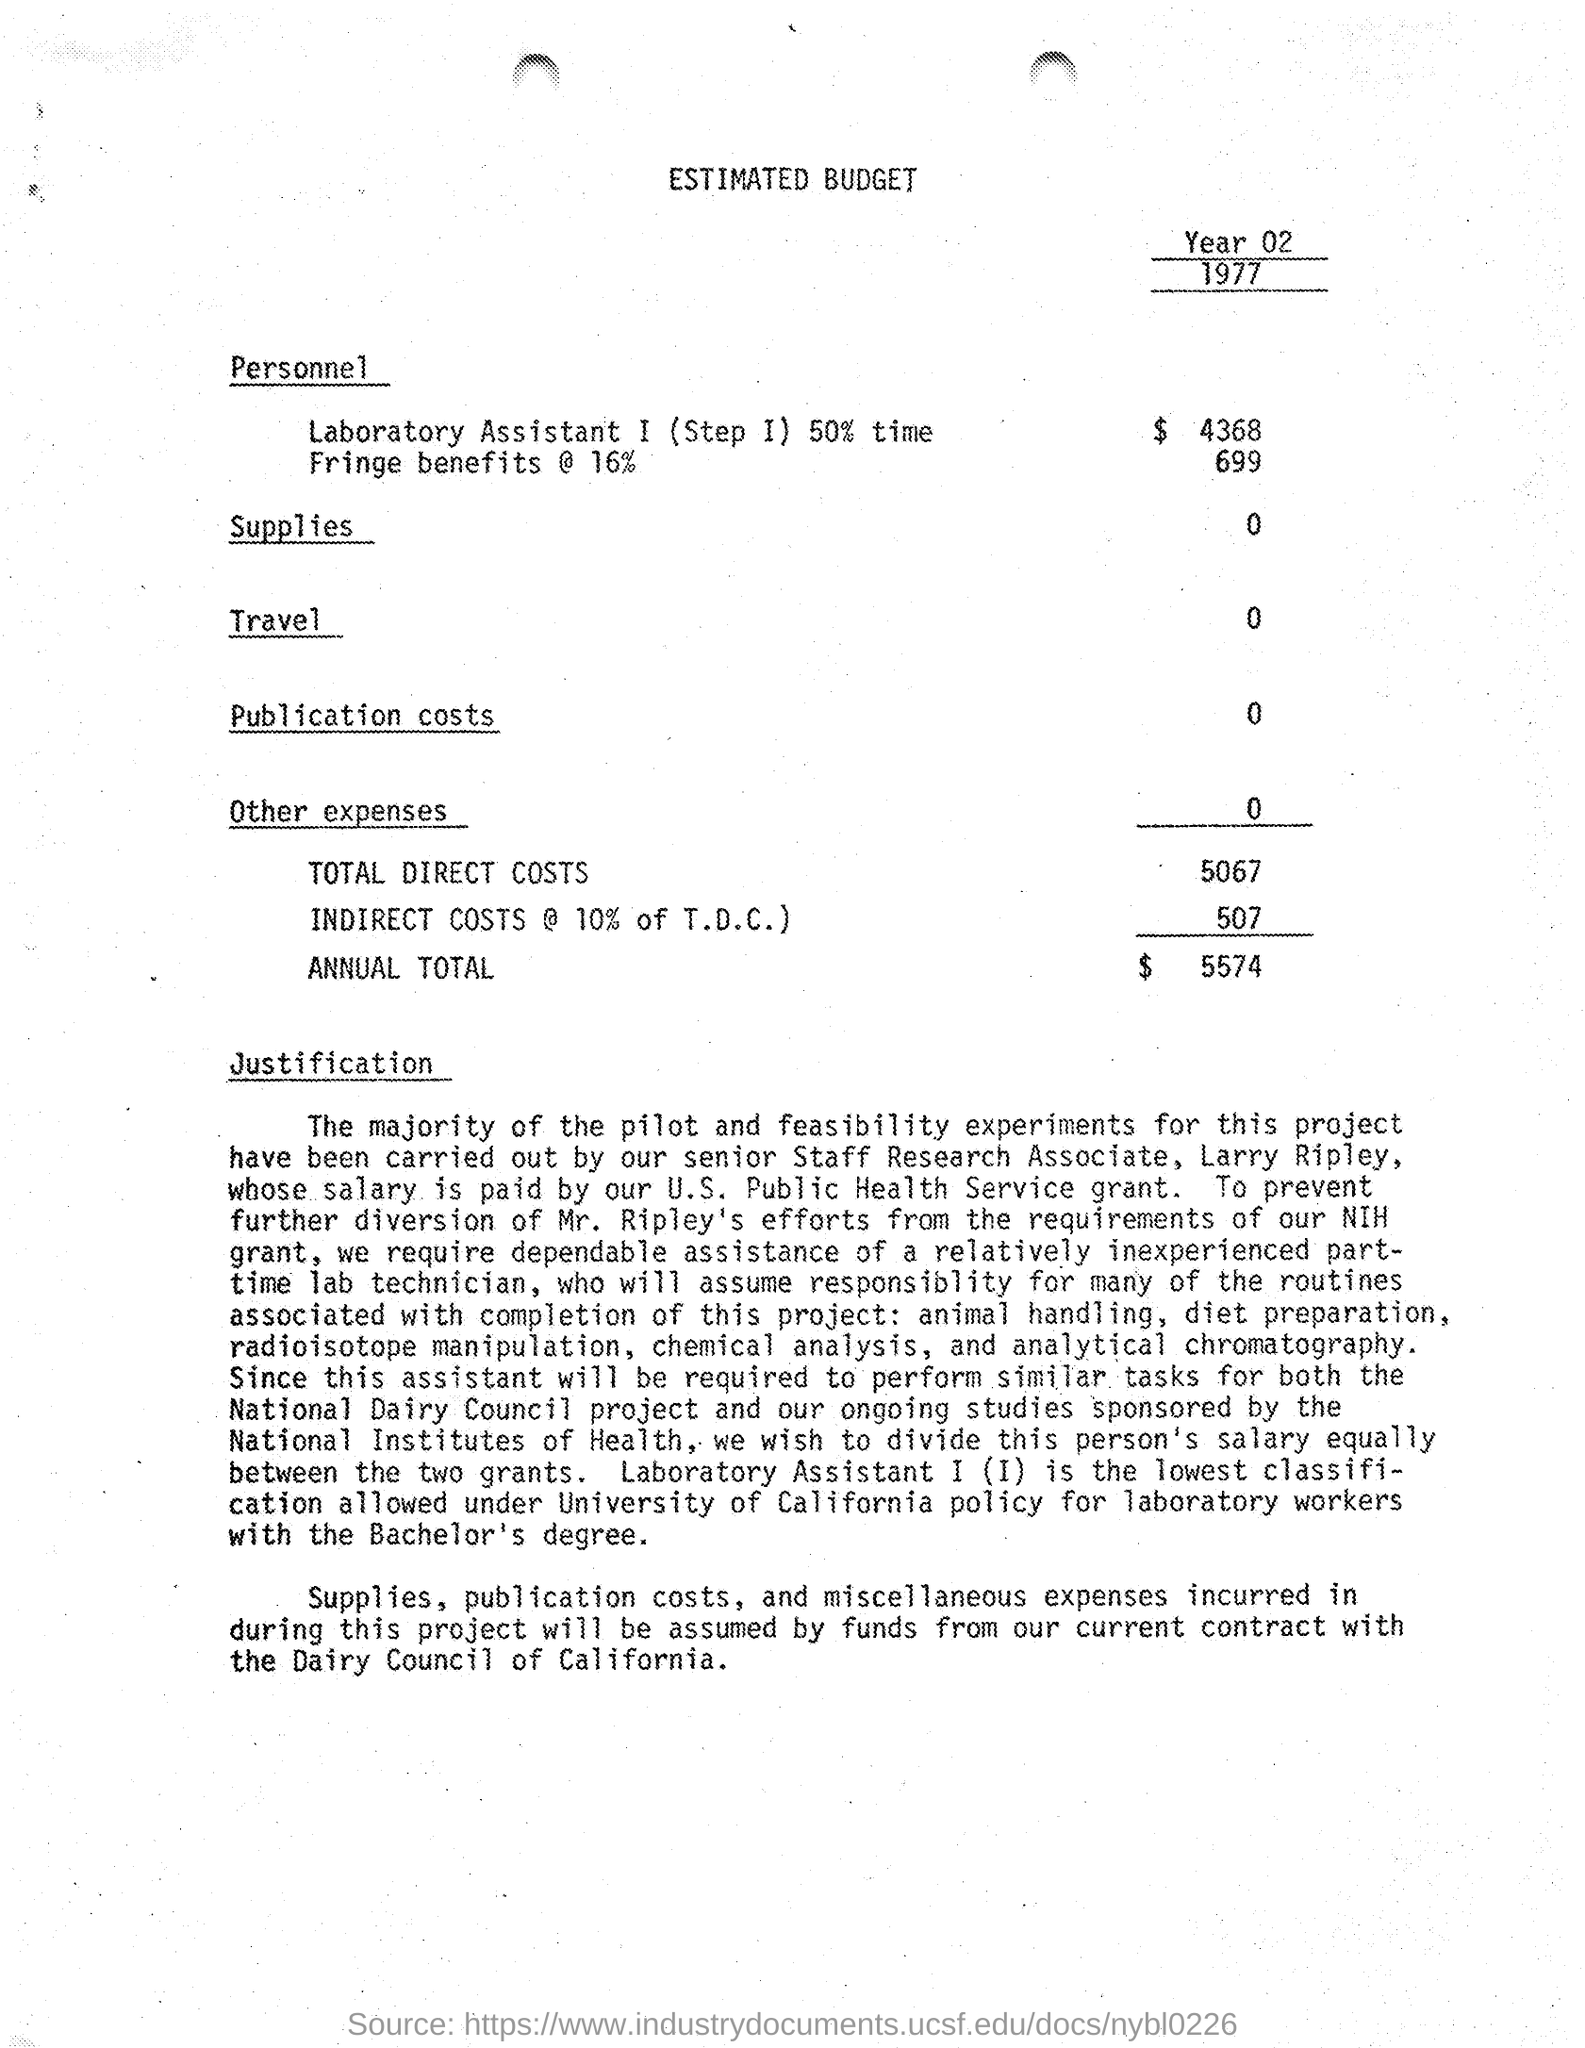What is the year of the estimated budget ?
Provide a short and direct response. Year 02. What is the amount for laboratory assistant 1 (step 1 ) 50% time as mentioned in the given budget ?
Provide a short and direct response. 4368. What is the amount given for fringe benefits @ 16 % as mentioned in the given budget ?
Provide a short and direct response. 699. What is the amount given for travel in the given budget ?
Make the answer very short. 0. What is the amount of total direct costs mentioned in the given budget ?
Your answer should be compact. 5067. What is the amount of indirect costs mentioned in the given budget ?
Offer a very short reply. 507. What is the amount of annual total mentioned in the given budget ?
Give a very brief answer. $ 5574. 